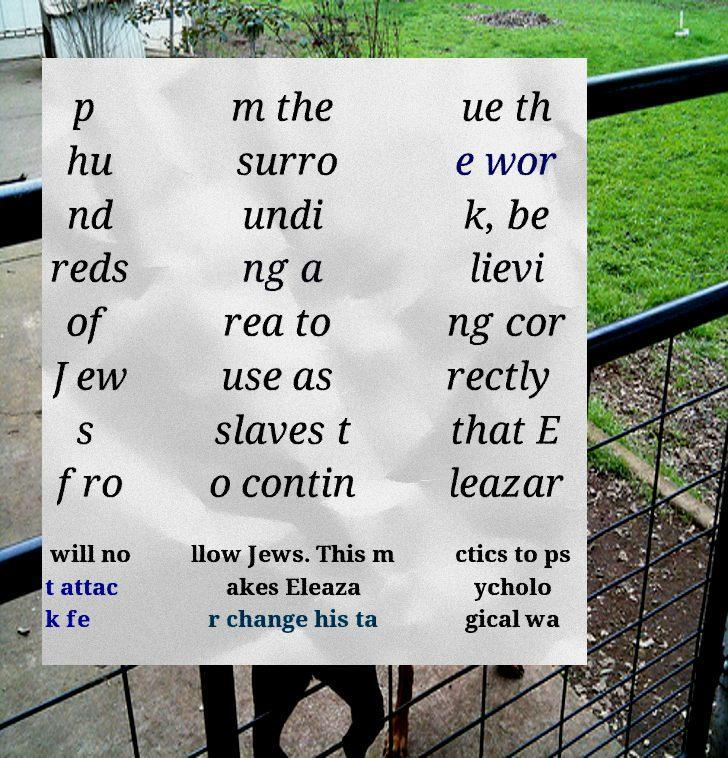There's text embedded in this image that I need extracted. Can you transcribe it verbatim? p hu nd reds of Jew s fro m the surro undi ng a rea to use as slaves t o contin ue th e wor k, be lievi ng cor rectly that E leazar will no t attac k fe llow Jews. This m akes Eleaza r change his ta ctics to ps ycholo gical wa 